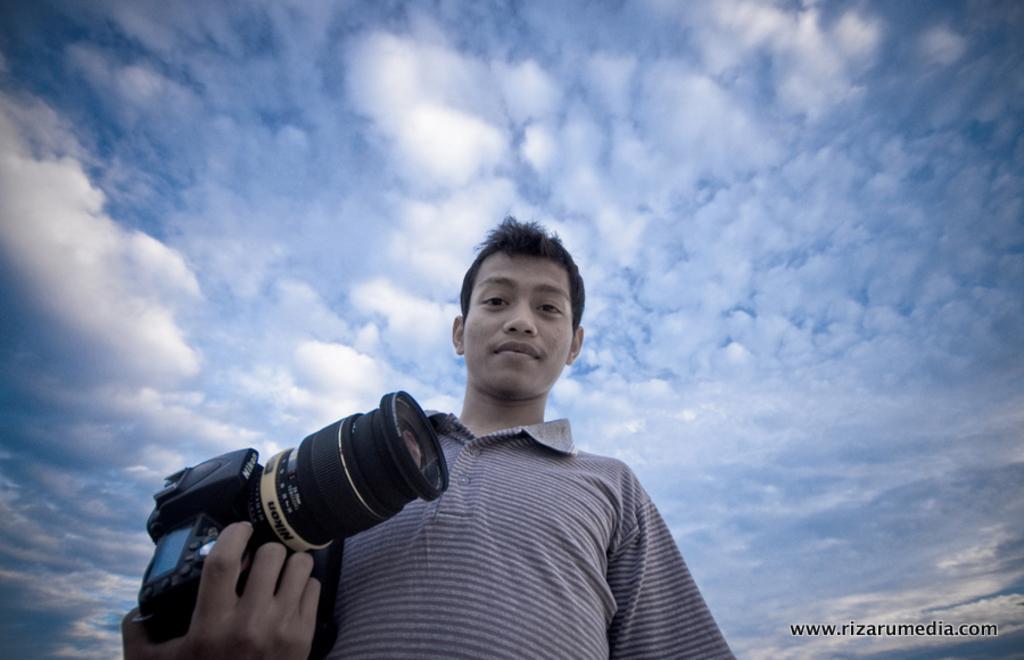Please provide a concise description of this image. In the image there is a man holding a camera, on top we can see a sky cloudy. 